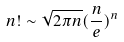Convert formula to latex. <formula><loc_0><loc_0><loc_500><loc_500>n ! \sim \sqrt { 2 \pi n } ( \frac { n } { e } ) ^ { n }</formula> 